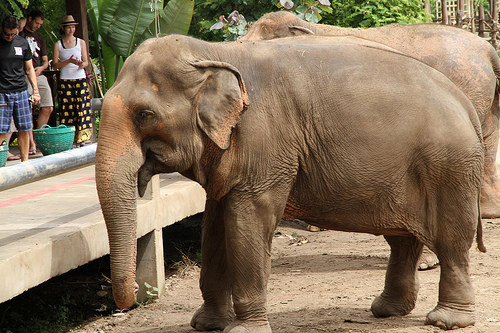If the image was part of a storybook, what might the plot be? In the storybook, the image could depict a pivotal moment in the tale of Ellie the Elephant. Ellie lives in a bustling zoo but dreams of exploring the world beyond. One day, she discovers a hidden passage that leads her out into the wild. With the help of her new friends – a brave tiger named Taro and a clever monkey named Mo – Ellie embarks on a quest to find a legendary waterfall said to grant any animal one special wish. Along the way, they face numerous challenges, from crossing treacherous terrains to outsmarting poachers. But through teamwork and determination, they reach the waterfall. Ellie makes her wish, not for herself, but for a better life for all zoo animals, turning the zoo into a sanctuary where animals and humans coexist happily ever after. Considering the people in the image, how might they fit into the story? The people in the image could be pivotal characters in Ellie's story. The man might be an empathetic zookeeper named sharegpt4v/sam, who understands Ellie's longing for freedom and aids in her escape. The girl could be sharegpt4v/sam’s daughter, Lily, who has a special bond with Ellie. She often visits and brings Ellie treats, telling her about the wonders of the world outside. Together, sharegpt4v/sam and Lily follow Ellie’s adventure, supporting her from the shadows, ensuring she stays safe and ultimately helping her bring back the magical changes to the zoo. Their bond with Ellie demonstrates the powerful connection between humans and animals, showing that with kindness and understanding, extraordinary things can happen. What might be the elephant's favorite memory from its adventure? Ellie's favorite memory from her adventure might be the moment she and her friends discovered a hidden, enchanted meadow. In this magical place, the plants glowed with ethereal light, and gentle, sparkling streams meandered through the land. Here, Ellie would feel an overwhelming sense of peace and connectedness with the world. It was a place where animals of all kinds gathered in harmony, sharing stories and enjoying the beauty of nature. This memory would remind Ellie of the unity and kindness that exist in the world, inspiring her to cherish her adventure and the friends she made along the way. 